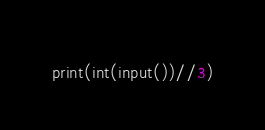Convert code to text. <code><loc_0><loc_0><loc_500><loc_500><_Python_>print(int(input())//3)</code> 